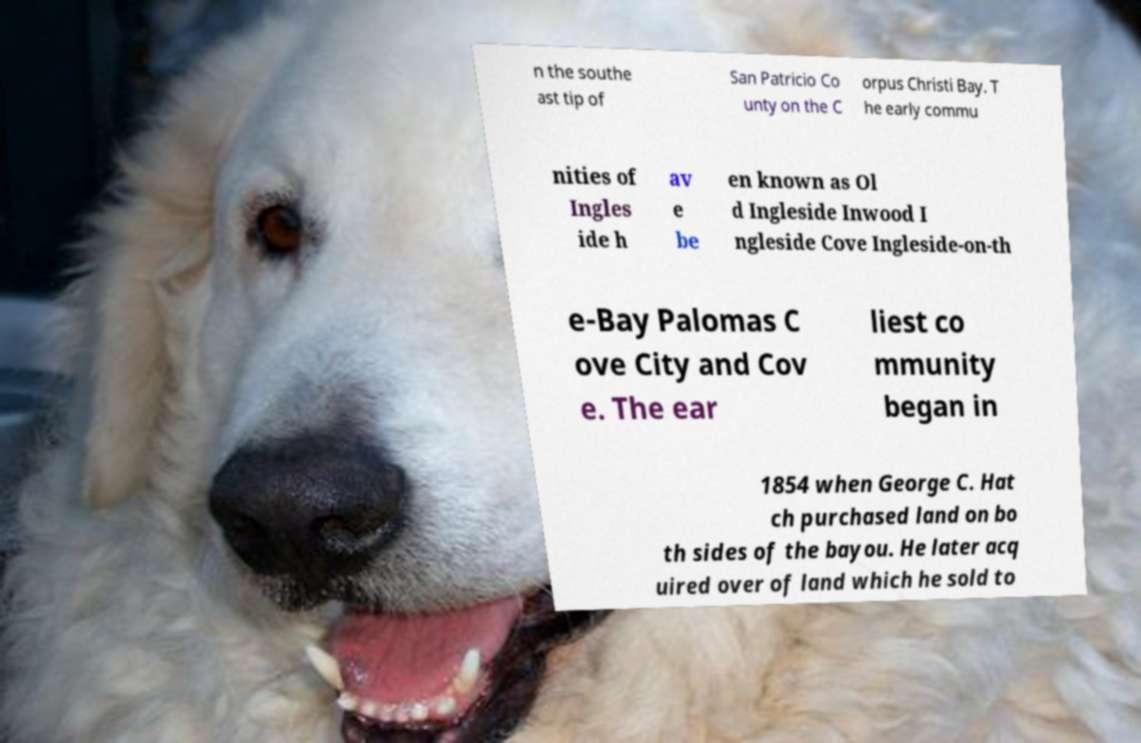Could you assist in decoding the text presented in this image and type it out clearly? n the southe ast tip of San Patricio Co unty on the C orpus Christi Bay. T he early commu nities of Ingles ide h av e be en known as Ol d Ingleside Inwood I ngleside Cove Ingleside-on-th e-Bay Palomas C ove City and Cov e. The ear liest co mmunity began in 1854 when George C. Hat ch purchased land on bo th sides of the bayou. He later acq uired over of land which he sold to 